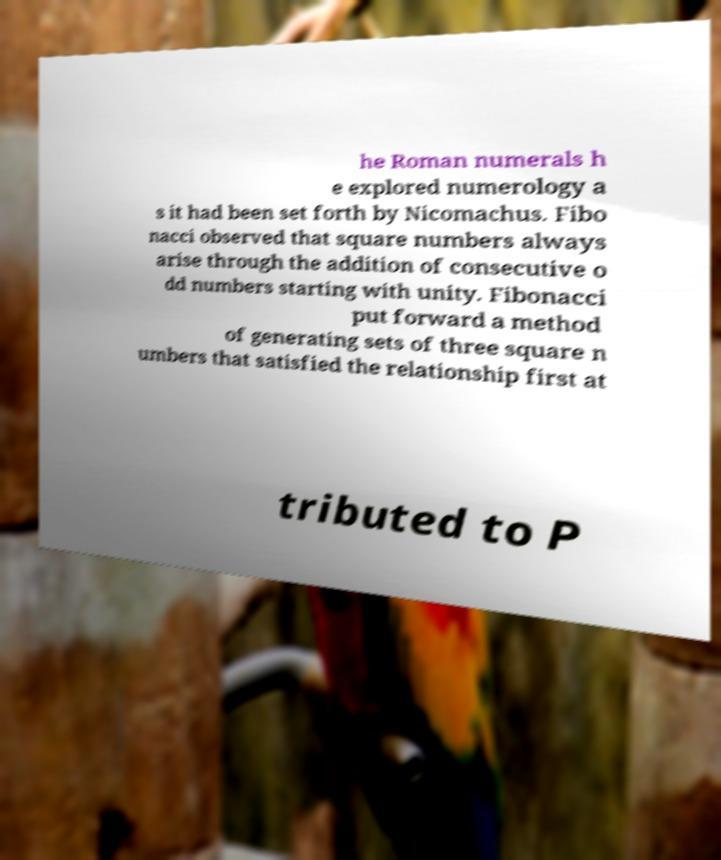Could you extract and type out the text from this image? he Roman numerals h e explored numerology a s it had been set forth by Nicomachus. Fibo nacci observed that square numbers always arise through the addition of consecutive o dd numbers starting with unity. Fibonacci put forward a method of generating sets of three square n umbers that satisfied the relationship first at tributed to P 